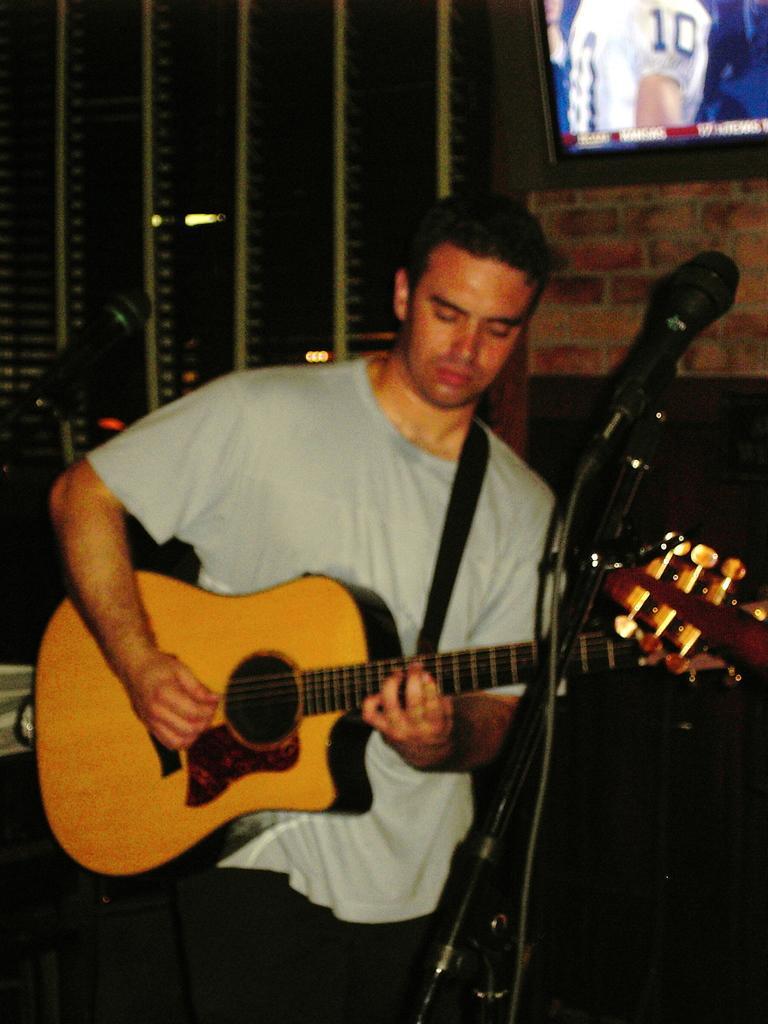Describe this image in one or two sentences. Here a man is standing and playing guitar in front of him there is a microphone,behind him there is a TV on the wall. 